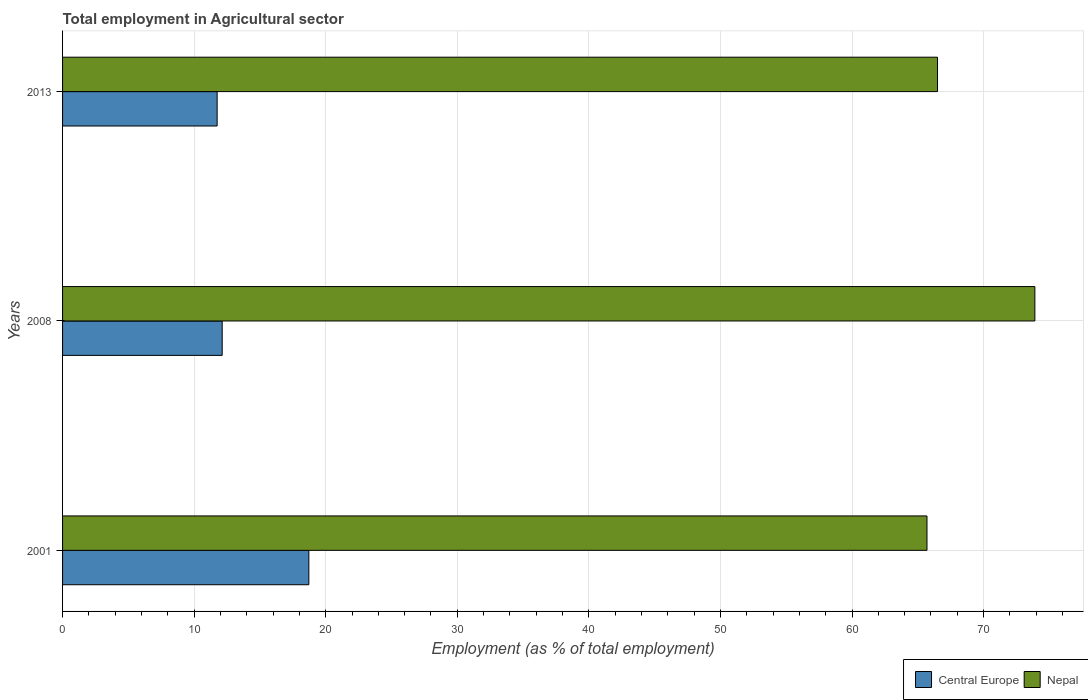How many bars are there on the 2nd tick from the top?
Offer a very short reply. 2. How many bars are there on the 3rd tick from the bottom?
Offer a very short reply. 2. In how many cases, is the number of bars for a given year not equal to the number of legend labels?
Provide a short and direct response. 0. What is the employment in agricultural sector in Nepal in 2001?
Keep it short and to the point. 65.7. Across all years, what is the maximum employment in agricultural sector in Nepal?
Make the answer very short. 73.9. Across all years, what is the minimum employment in agricultural sector in Central Europe?
Ensure brevity in your answer.  11.75. In which year was the employment in agricultural sector in Nepal maximum?
Give a very brief answer. 2008. What is the total employment in agricultural sector in Central Europe in the graph?
Offer a terse response. 42.6. What is the difference between the employment in agricultural sector in Nepal in 2001 and that in 2008?
Provide a succinct answer. -8.2. What is the difference between the employment in agricultural sector in Central Europe in 2008 and the employment in agricultural sector in Nepal in 2001?
Provide a short and direct response. -53.57. What is the average employment in agricultural sector in Central Europe per year?
Your response must be concise. 14.2. In the year 2008, what is the difference between the employment in agricultural sector in Nepal and employment in agricultural sector in Central Europe?
Ensure brevity in your answer.  61.77. What is the ratio of the employment in agricultural sector in Central Europe in 2001 to that in 2013?
Ensure brevity in your answer.  1.59. Is the employment in agricultural sector in Nepal in 2001 less than that in 2013?
Provide a succinct answer. Yes. Is the difference between the employment in agricultural sector in Nepal in 2001 and 2013 greater than the difference between the employment in agricultural sector in Central Europe in 2001 and 2013?
Provide a short and direct response. No. What is the difference between the highest and the second highest employment in agricultural sector in Nepal?
Your response must be concise. 7.4. What is the difference between the highest and the lowest employment in agricultural sector in Nepal?
Offer a very short reply. 8.2. Is the sum of the employment in agricultural sector in Nepal in 2001 and 2013 greater than the maximum employment in agricultural sector in Central Europe across all years?
Your response must be concise. Yes. What does the 2nd bar from the top in 2001 represents?
Give a very brief answer. Central Europe. What does the 2nd bar from the bottom in 2008 represents?
Your response must be concise. Nepal. How many years are there in the graph?
Keep it short and to the point. 3. What is the difference between two consecutive major ticks on the X-axis?
Provide a succinct answer. 10. What is the title of the graph?
Your response must be concise. Total employment in Agricultural sector. What is the label or title of the X-axis?
Provide a succinct answer. Employment (as % of total employment). What is the Employment (as % of total employment) of Central Europe in 2001?
Provide a short and direct response. 18.72. What is the Employment (as % of total employment) in Nepal in 2001?
Your response must be concise. 65.7. What is the Employment (as % of total employment) of Central Europe in 2008?
Ensure brevity in your answer.  12.13. What is the Employment (as % of total employment) of Nepal in 2008?
Provide a succinct answer. 73.9. What is the Employment (as % of total employment) in Central Europe in 2013?
Keep it short and to the point. 11.75. What is the Employment (as % of total employment) in Nepal in 2013?
Offer a very short reply. 66.5. Across all years, what is the maximum Employment (as % of total employment) in Central Europe?
Provide a short and direct response. 18.72. Across all years, what is the maximum Employment (as % of total employment) in Nepal?
Your response must be concise. 73.9. Across all years, what is the minimum Employment (as % of total employment) of Central Europe?
Offer a very short reply. 11.75. Across all years, what is the minimum Employment (as % of total employment) of Nepal?
Offer a terse response. 65.7. What is the total Employment (as % of total employment) in Central Europe in the graph?
Keep it short and to the point. 42.6. What is the total Employment (as % of total employment) in Nepal in the graph?
Make the answer very short. 206.1. What is the difference between the Employment (as % of total employment) of Central Europe in 2001 and that in 2008?
Offer a terse response. 6.59. What is the difference between the Employment (as % of total employment) of Central Europe in 2001 and that in 2013?
Ensure brevity in your answer.  6.97. What is the difference between the Employment (as % of total employment) in Central Europe in 2008 and that in 2013?
Offer a terse response. 0.38. What is the difference between the Employment (as % of total employment) of Central Europe in 2001 and the Employment (as % of total employment) of Nepal in 2008?
Give a very brief answer. -55.18. What is the difference between the Employment (as % of total employment) of Central Europe in 2001 and the Employment (as % of total employment) of Nepal in 2013?
Ensure brevity in your answer.  -47.78. What is the difference between the Employment (as % of total employment) in Central Europe in 2008 and the Employment (as % of total employment) in Nepal in 2013?
Give a very brief answer. -54.37. What is the average Employment (as % of total employment) of Central Europe per year?
Your answer should be very brief. 14.2. What is the average Employment (as % of total employment) in Nepal per year?
Ensure brevity in your answer.  68.7. In the year 2001, what is the difference between the Employment (as % of total employment) of Central Europe and Employment (as % of total employment) of Nepal?
Your response must be concise. -46.98. In the year 2008, what is the difference between the Employment (as % of total employment) of Central Europe and Employment (as % of total employment) of Nepal?
Ensure brevity in your answer.  -61.77. In the year 2013, what is the difference between the Employment (as % of total employment) in Central Europe and Employment (as % of total employment) in Nepal?
Your answer should be compact. -54.75. What is the ratio of the Employment (as % of total employment) in Central Europe in 2001 to that in 2008?
Ensure brevity in your answer.  1.54. What is the ratio of the Employment (as % of total employment) of Nepal in 2001 to that in 2008?
Ensure brevity in your answer.  0.89. What is the ratio of the Employment (as % of total employment) of Central Europe in 2001 to that in 2013?
Offer a terse response. 1.59. What is the ratio of the Employment (as % of total employment) of Central Europe in 2008 to that in 2013?
Your response must be concise. 1.03. What is the ratio of the Employment (as % of total employment) of Nepal in 2008 to that in 2013?
Provide a short and direct response. 1.11. What is the difference between the highest and the second highest Employment (as % of total employment) of Central Europe?
Your response must be concise. 6.59. What is the difference between the highest and the lowest Employment (as % of total employment) in Central Europe?
Your response must be concise. 6.97. What is the difference between the highest and the lowest Employment (as % of total employment) of Nepal?
Your response must be concise. 8.2. 